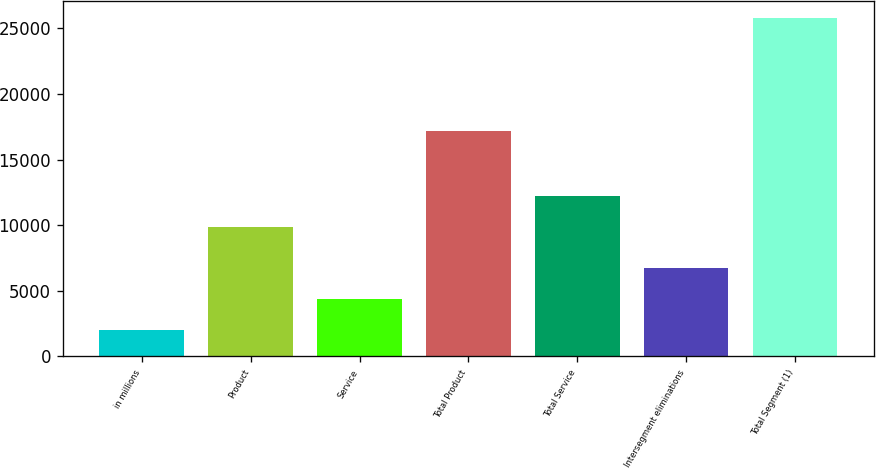Convert chart. <chart><loc_0><loc_0><loc_500><loc_500><bar_chart><fcel>in millions<fcel>Product<fcel>Service<fcel>Total Product<fcel>Total Service<fcel>Intersegment eliminations<fcel>Total Segment (1)<nl><fcel>2017<fcel>9841<fcel>4395.6<fcel>17140<fcel>12219.6<fcel>6774.2<fcel>25803<nl></chart> 